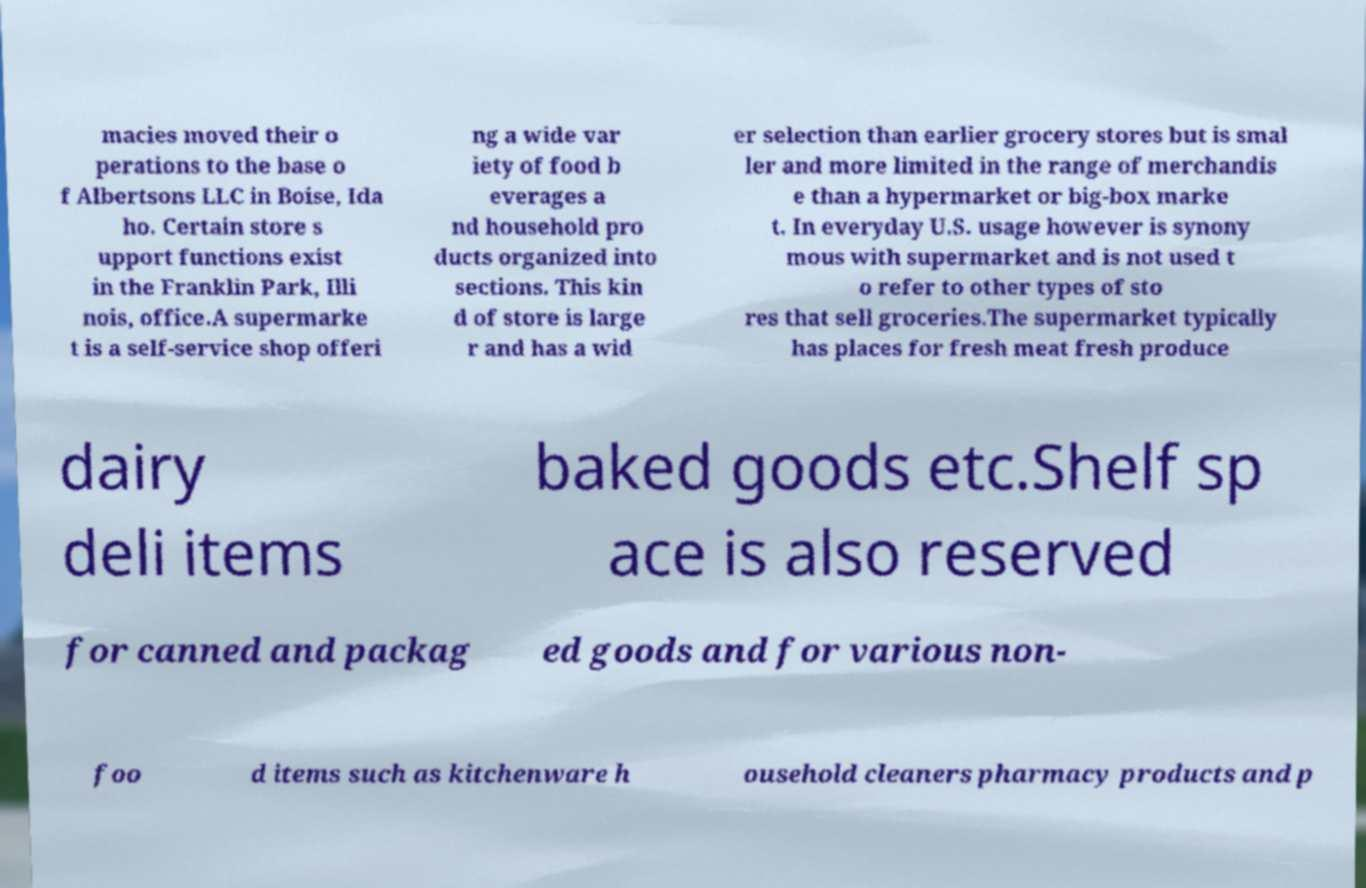For documentation purposes, I need the text within this image transcribed. Could you provide that? macies moved their o perations to the base o f Albertsons LLC in Boise, Ida ho. Certain store s upport functions exist in the Franklin Park, Illi nois, office.A supermarke t is a self-service shop offeri ng a wide var iety of food b everages a nd household pro ducts organized into sections. This kin d of store is large r and has a wid er selection than earlier grocery stores but is smal ler and more limited in the range of merchandis e than a hypermarket or big-box marke t. In everyday U.S. usage however is synony mous with supermarket and is not used t o refer to other types of sto res that sell groceries.The supermarket typically has places for fresh meat fresh produce dairy deli items baked goods etc.Shelf sp ace is also reserved for canned and packag ed goods and for various non- foo d items such as kitchenware h ousehold cleaners pharmacy products and p 